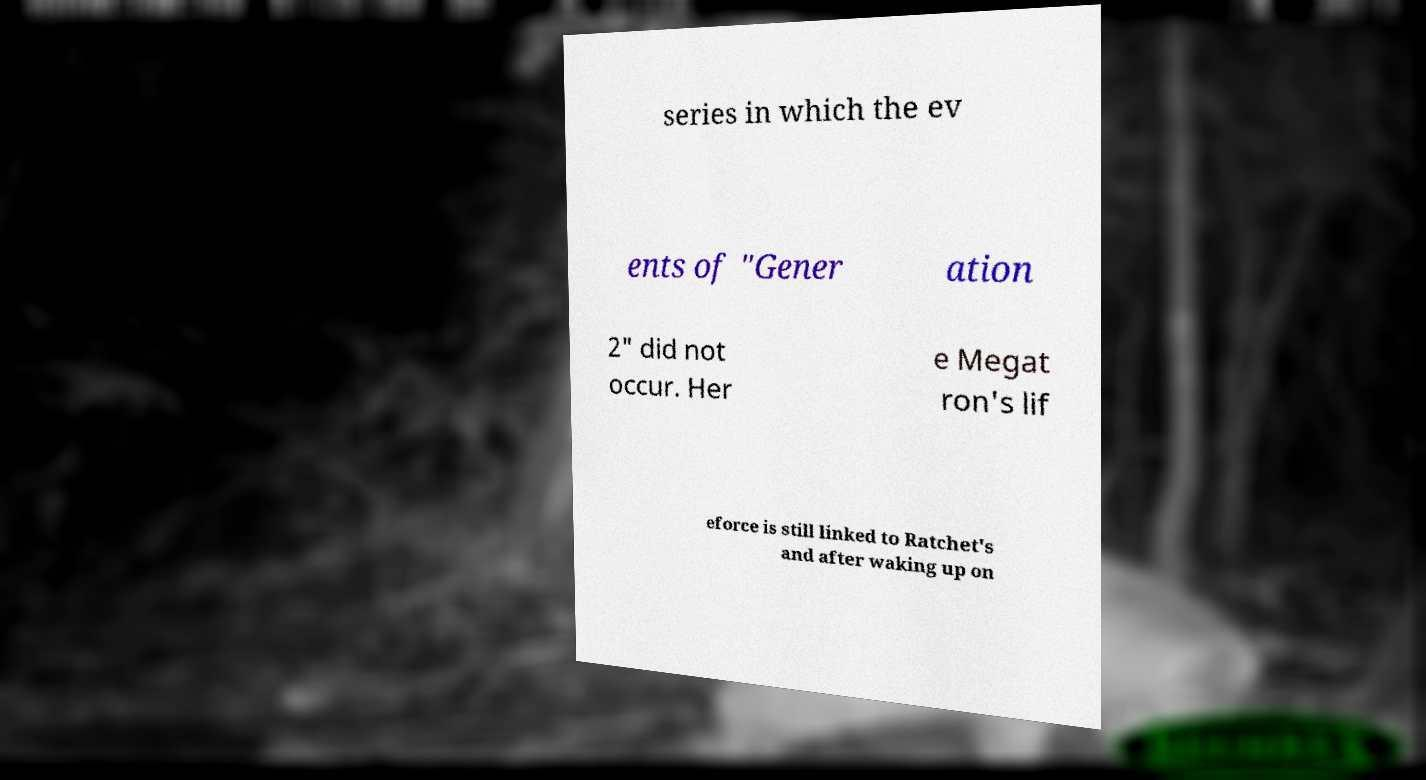Please identify and transcribe the text found in this image. series in which the ev ents of "Gener ation 2" did not occur. Her e Megat ron's lif eforce is still linked to Ratchet's and after waking up on 